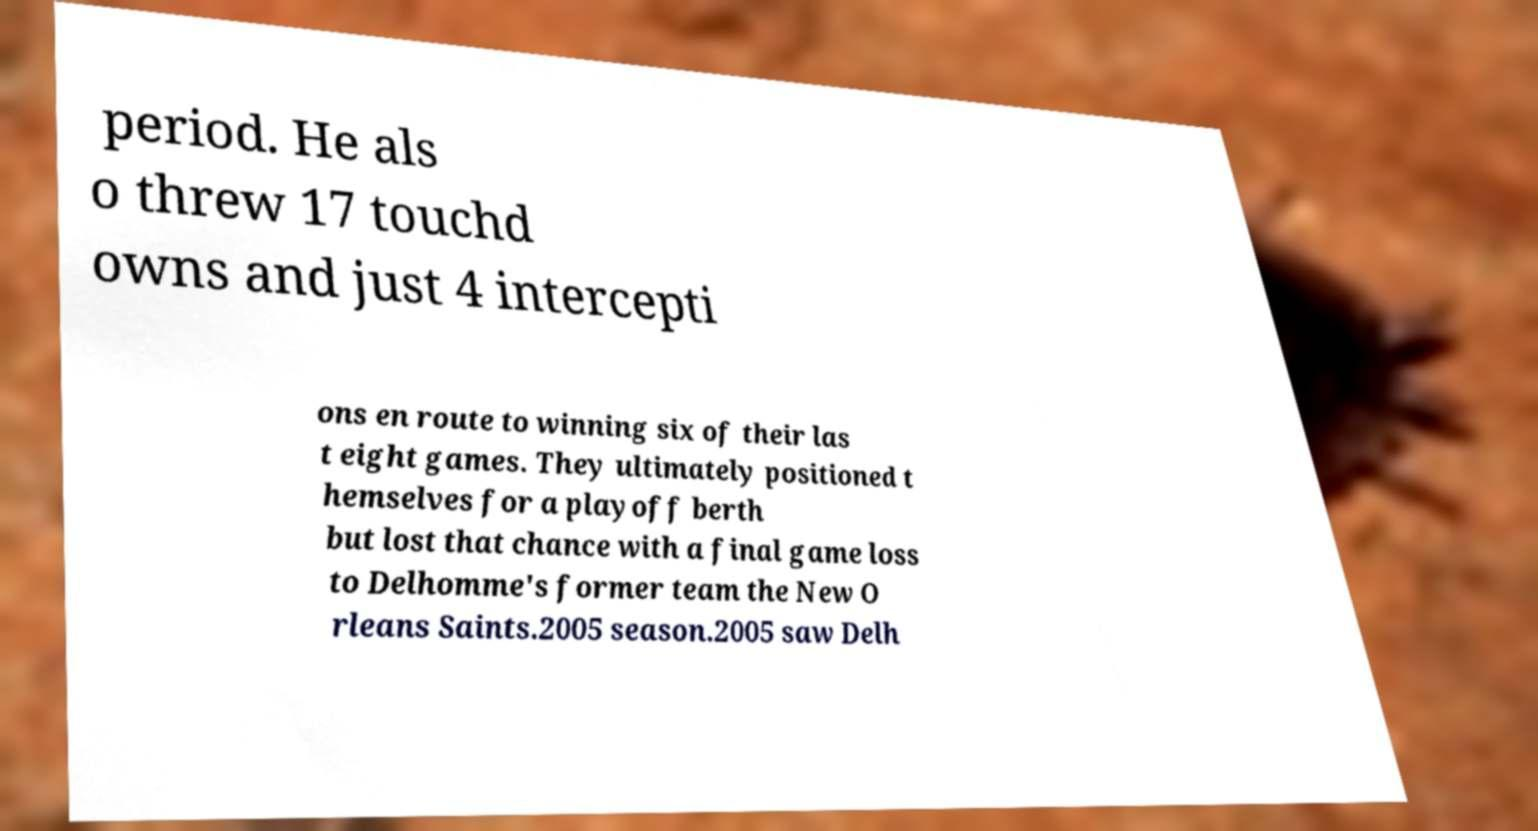There's text embedded in this image that I need extracted. Can you transcribe it verbatim? period. He als o threw 17 touchd owns and just 4 intercepti ons en route to winning six of their las t eight games. They ultimately positioned t hemselves for a playoff berth but lost that chance with a final game loss to Delhomme's former team the New O rleans Saints.2005 season.2005 saw Delh 